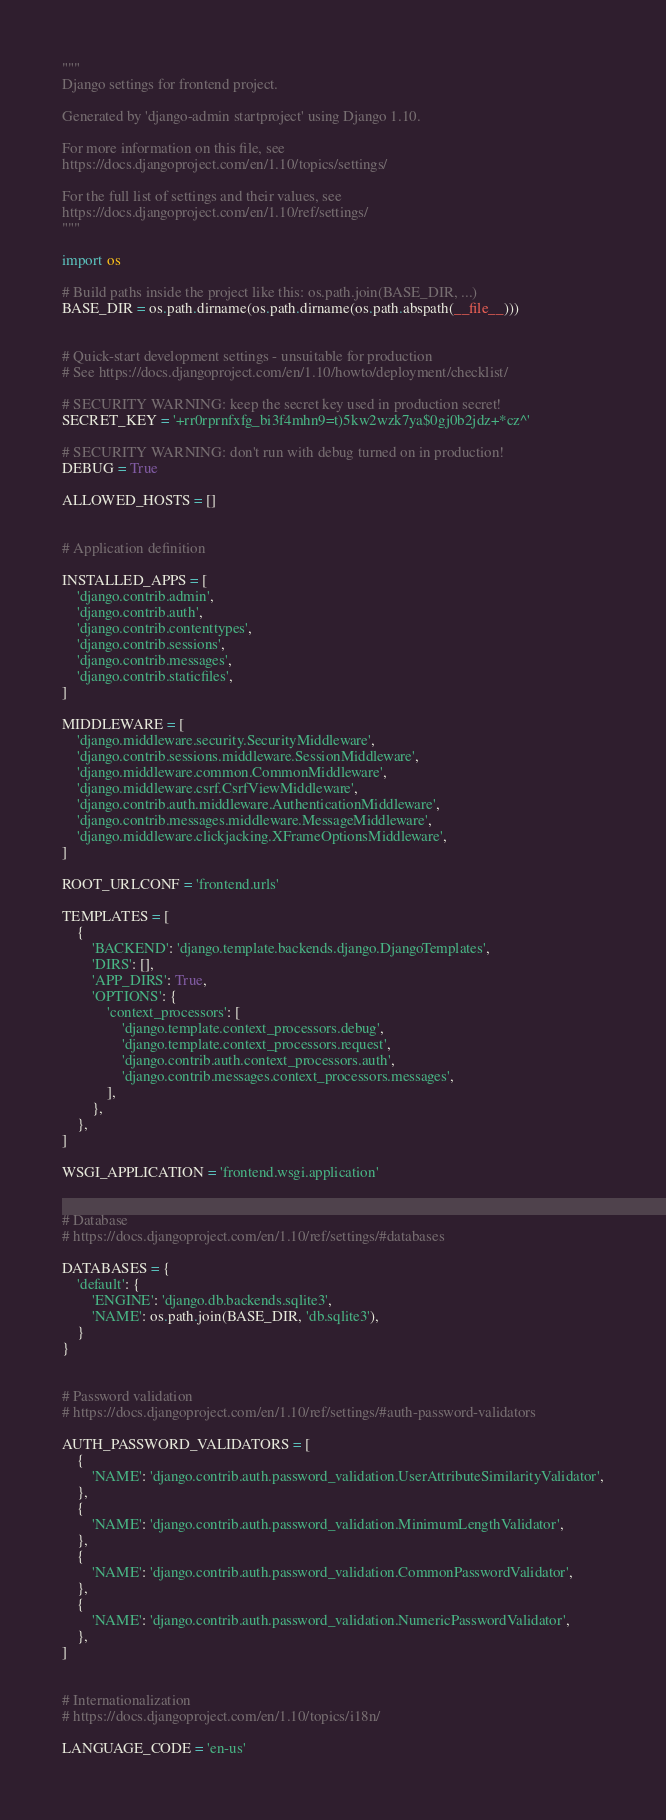<code> <loc_0><loc_0><loc_500><loc_500><_Python_>"""
Django settings for frontend project.

Generated by 'django-admin startproject' using Django 1.10.

For more information on this file, see
https://docs.djangoproject.com/en/1.10/topics/settings/

For the full list of settings and their values, see
https://docs.djangoproject.com/en/1.10/ref/settings/
"""

import os

# Build paths inside the project like this: os.path.join(BASE_DIR, ...)
BASE_DIR = os.path.dirname(os.path.dirname(os.path.abspath(__file__)))


# Quick-start development settings - unsuitable for production
# See https://docs.djangoproject.com/en/1.10/howto/deployment/checklist/

# SECURITY WARNING: keep the secret key used in production secret!
SECRET_KEY = '+rr0rprnfxfg_bi3f4mhn9=t)5kw2wzk7ya$0gj0b2jdz+*cz^'

# SECURITY WARNING: don't run with debug turned on in production!
DEBUG = True

ALLOWED_HOSTS = []


# Application definition

INSTALLED_APPS = [
    'django.contrib.admin',
    'django.contrib.auth',
    'django.contrib.contenttypes',
    'django.contrib.sessions',
    'django.contrib.messages',
    'django.contrib.staticfiles',
]

MIDDLEWARE = [
    'django.middleware.security.SecurityMiddleware',
    'django.contrib.sessions.middleware.SessionMiddleware',
    'django.middleware.common.CommonMiddleware',
    'django.middleware.csrf.CsrfViewMiddleware',
    'django.contrib.auth.middleware.AuthenticationMiddleware',
    'django.contrib.messages.middleware.MessageMiddleware',
    'django.middleware.clickjacking.XFrameOptionsMiddleware',
]

ROOT_URLCONF = 'frontend.urls'

TEMPLATES = [
    {
        'BACKEND': 'django.template.backends.django.DjangoTemplates',
        'DIRS': [],
        'APP_DIRS': True,
        'OPTIONS': {
            'context_processors': [
                'django.template.context_processors.debug',
                'django.template.context_processors.request',
                'django.contrib.auth.context_processors.auth',
                'django.contrib.messages.context_processors.messages',
            ],
        },
    },
]

WSGI_APPLICATION = 'frontend.wsgi.application'


# Database
# https://docs.djangoproject.com/en/1.10/ref/settings/#databases

DATABASES = {
    'default': {
        'ENGINE': 'django.db.backends.sqlite3',
        'NAME': os.path.join(BASE_DIR, 'db.sqlite3'),
    }
}


# Password validation
# https://docs.djangoproject.com/en/1.10/ref/settings/#auth-password-validators

AUTH_PASSWORD_VALIDATORS = [
    {
        'NAME': 'django.contrib.auth.password_validation.UserAttributeSimilarityValidator',
    },
    {
        'NAME': 'django.contrib.auth.password_validation.MinimumLengthValidator',
    },
    {
        'NAME': 'django.contrib.auth.password_validation.CommonPasswordValidator',
    },
    {
        'NAME': 'django.contrib.auth.password_validation.NumericPasswordValidator',
    },
]


# Internationalization
# https://docs.djangoproject.com/en/1.10/topics/i18n/

LANGUAGE_CODE = 'en-us'
</code> 